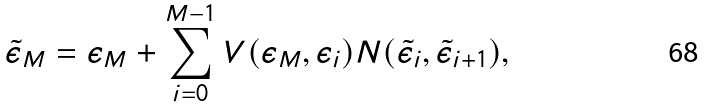Convert formula to latex. <formula><loc_0><loc_0><loc_500><loc_500>\tilde { \epsilon } _ { M } = \epsilon _ { M } + \sum _ { i = 0 } ^ { M - 1 } V ( \epsilon _ { M } , \epsilon _ { i } ) N ( \tilde { \epsilon } _ { i } , \tilde { \epsilon } _ { i + 1 } ) ,</formula> 